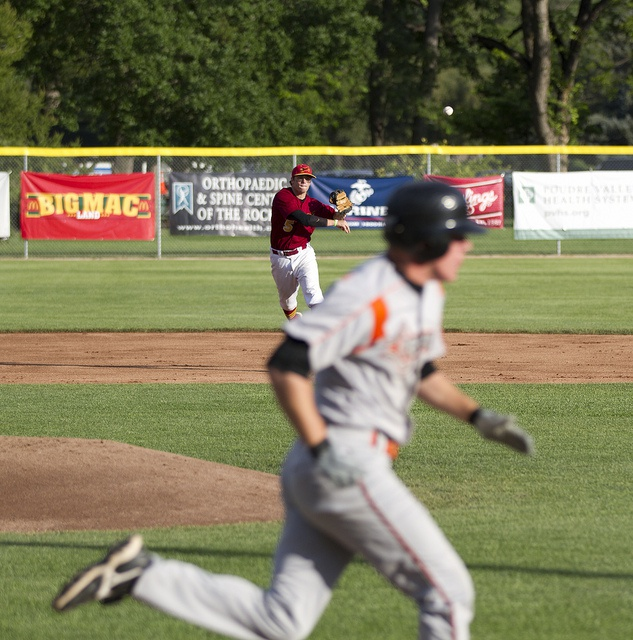Describe the objects in this image and their specific colors. I can see people in darkgreen, lightgray, gray, darkgray, and black tones, people in darkgreen, black, white, gray, and maroon tones, baseball glove in darkgreen, tan, black, and gray tones, and sports ball in darkgreen, ivory, gray, darkgray, and black tones in this image. 